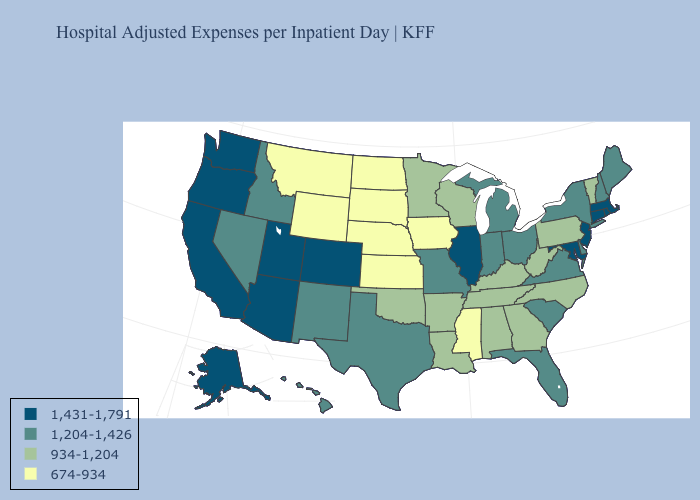Name the states that have a value in the range 934-1,204?
Quick response, please. Alabama, Arkansas, Georgia, Kentucky, Louisiana, Minnesota, North Carolina, Oklahoma, Pennsylvania, Tennessee, Vermont, West Virginia, Wisconsin. Among the states that border California , does Nevada have the lowest value?
Keep it brief. Yes. Does Missouri have a lower value than Illinois?
Write a very short answer. Yes. Does Nevada have the lowest value in the USA?
Keep it brief. No. What is the value of Kansas?
Quick response, please. 674-934. What is the value of New York?
Concise answer only. 1,204-1,426. Is the legend a continuous bar?
Write a very short answer. No. Name the states that have a value in the range 1,204-1,426?
Give a very brief answer. Delaware, Florida, Hawaii, Idaho, Indiana, Maine, Michigan, Missouri, Nevada, New Hampshire, New Mexico, New York, Ohio, South Carolina, Texas, Virginia. What is the highest value in the USA?
Be succinct. 1,431-1,791. Does the map have missing data?
Concise answer only. No. Does the first symbol in the legend represent the smallest category?
Quick response, please. No. What is the highest value in states that border Washington?
Keep it brief. 1,431-1,791. Name the states that have a value in the range 674-934?
Quick response, please. Iowa, Kansas, Mississippi, Montana, Nebraska, North Dakota, South Dakota, Wyoming. What is the value of New Mexico?
Short answer required. 1,204-1,426. What is the lowest value in states that border Minnesota?
Answer briefly. 674-934. 